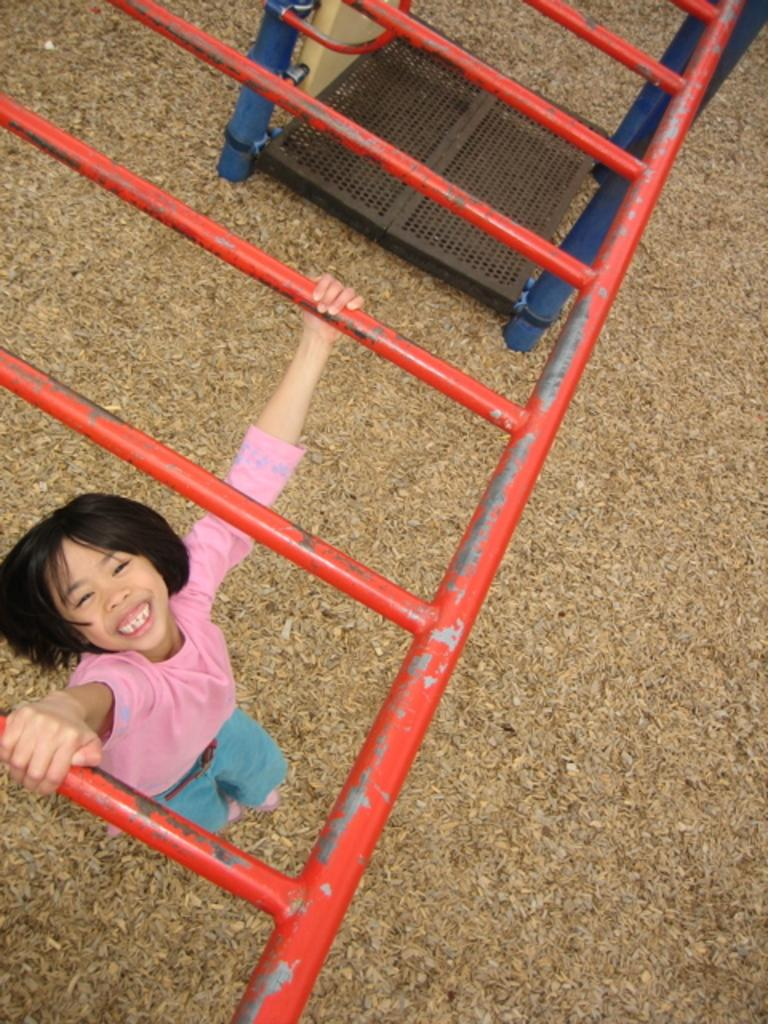What is the girl doing in the image? The girl is hanging onto rods in the image. What can be seen in the background of the image? There is a mesh visible in the background of the image. What type of floor can be seen in the image? There is no floor visible in the image; it only shows the girl hanging onto rods and the mesh in the background. 